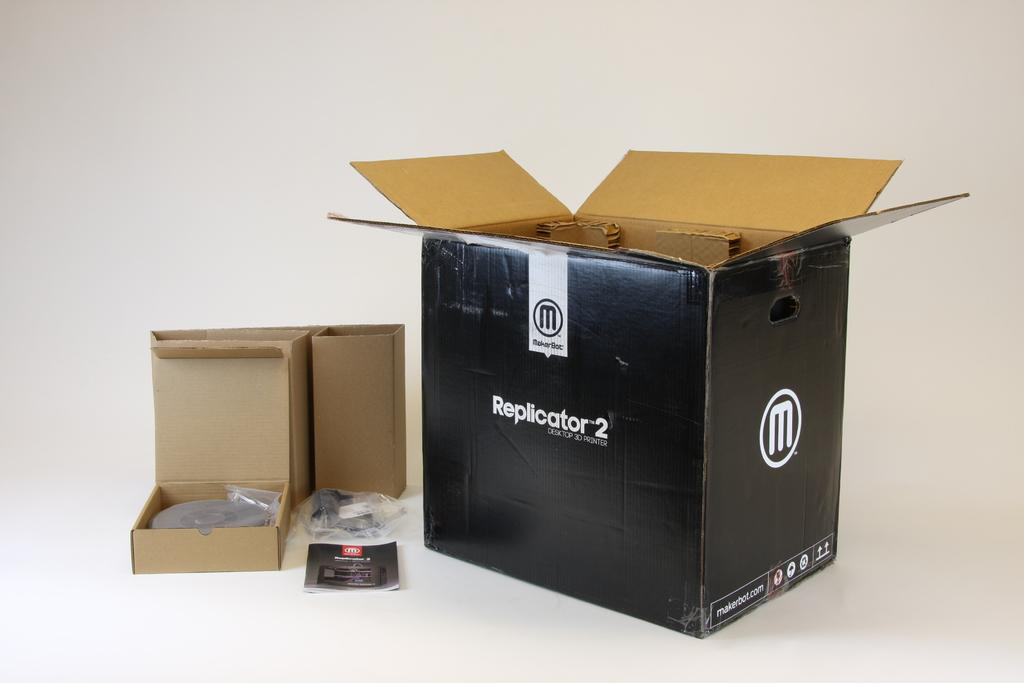<image>
Give a short and clear explanation of the subsequent image. A large black box that says Replicator 2 on it and a couple of smaller boxes. 